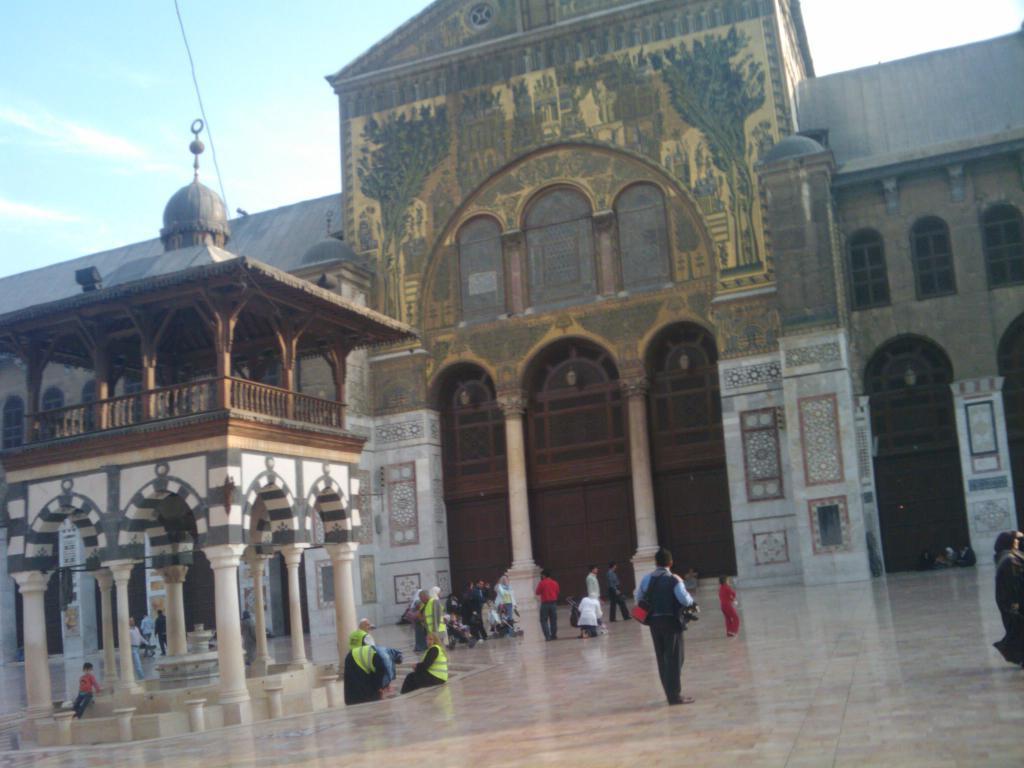Can you describe this image briefly? In this image, we can see a building, shed, pillars, railings, walls, windows. Here we can see a group of people. Few are sitting and standing. Top of the image, there is a sky. 